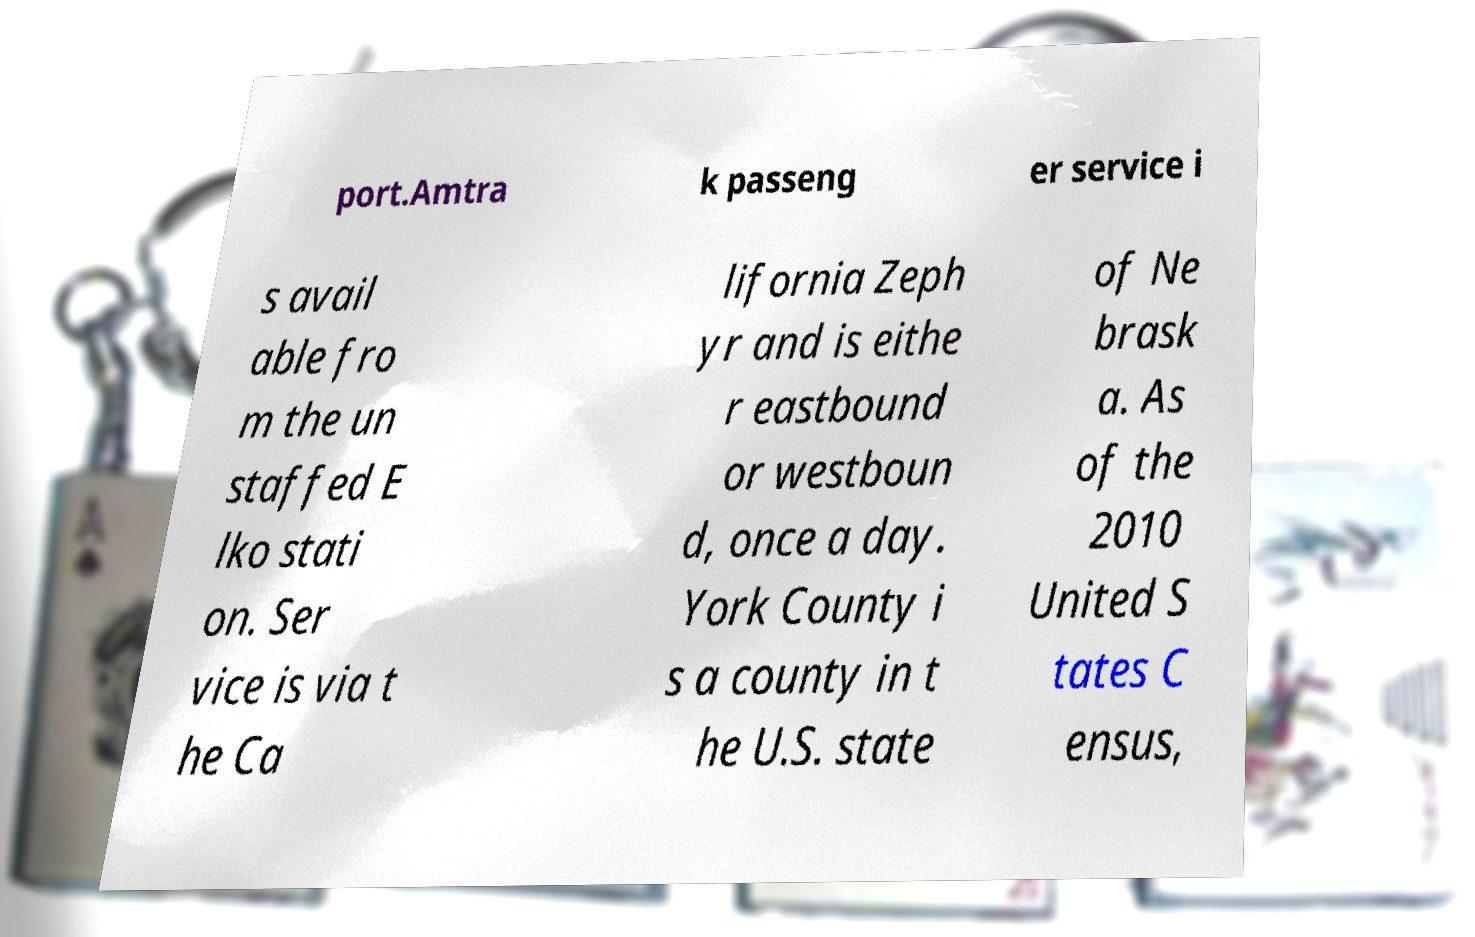Could you assist in decoding the text presented in this image and type it out clearly? port.Amtra k passeng er service i s avail able fro m the un staffed E lko stati on. Ser vice is via t he Ca lifornia Zeph yr and is eithe r eastbound or westboun d, once a day. York County i s a county in t he U.S. state of Ne brask a. As of the 2010 United S tates C ensus, 